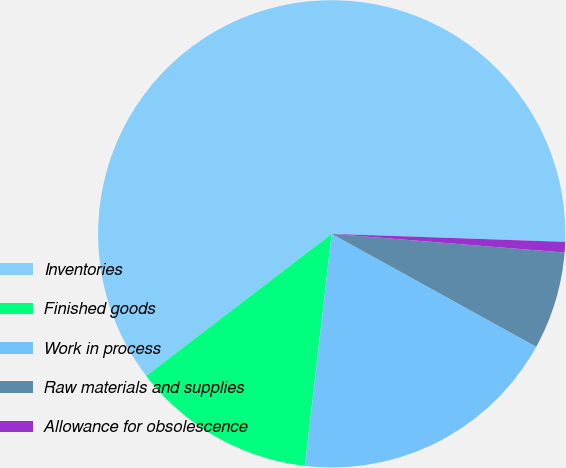Convert chart to OTSL. <chart><loc_0><loc_0><loc_500><loc_500><pie_chart><fcel>Inventories<fcel>Finished goods<fcel>Work in process<fcel>Raw materials and supplies<fcel>Allowance for obsolescence<nl><fcel>60.95%<fcel>12.77%<fcel>18.8%<fcel>6.75%<fcel>0.73%<nl></chart> 